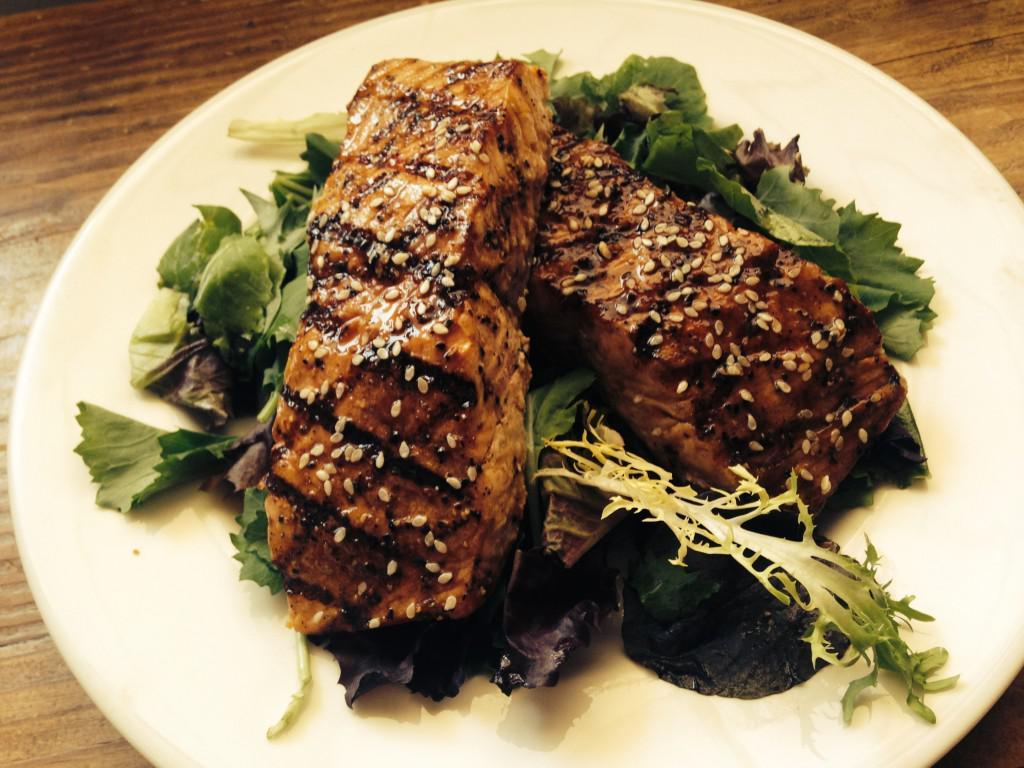What is on the plate that is visible in the image? There is food on a plate in the image. Where is the plate located in the image? The plate is placed on a table in the image. What type of cart is used to transport the food in the image? There is no cart present in the image; the food is on a plate placed on a table. What color is the thread used to decorate the food in the image? There is no thread present in the image; the food is simply on a plate. 